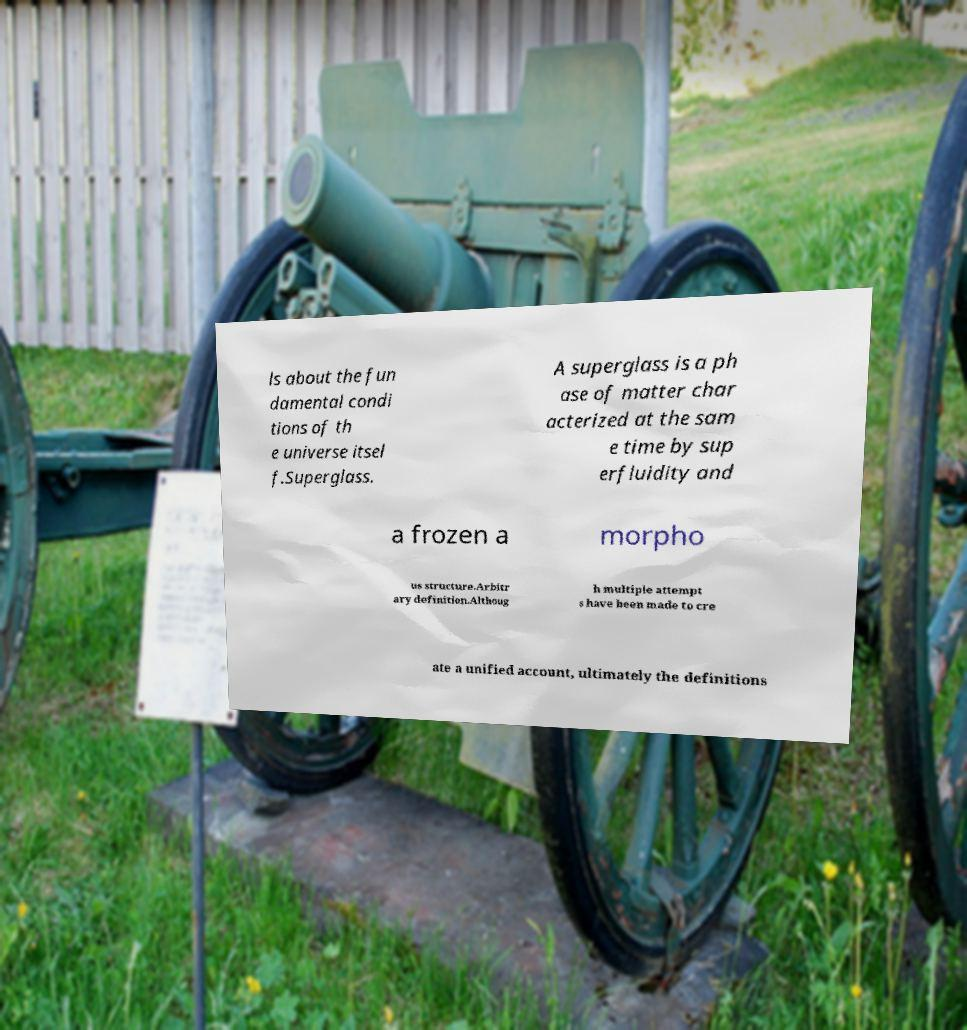I need the written content from this picture converted into text. Can you do that? ls about the fun damental condi tions of th e universe itsel f.Superglass. A superglass is a ph ase of matter char acterized at the sam e time by sup erfluidity and a frozen a morpho us structure.Arbitr ary definition.Althoug h multiple attempt s have been made to cre ate a unified account, ultimately the definitions 